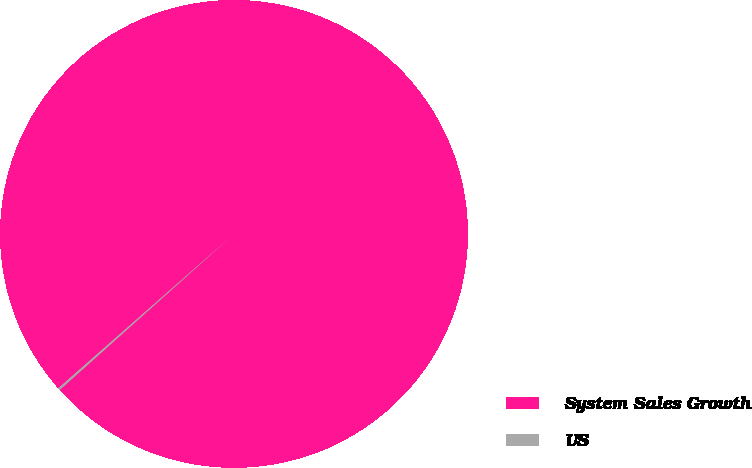<chart> <loc_0><loc_0><loc_500><loc_500><pie_chart><fcel>System Sales Growth<fcel>US<nl><fcel>99.85%<fcel>0.15%<nl></chart> 